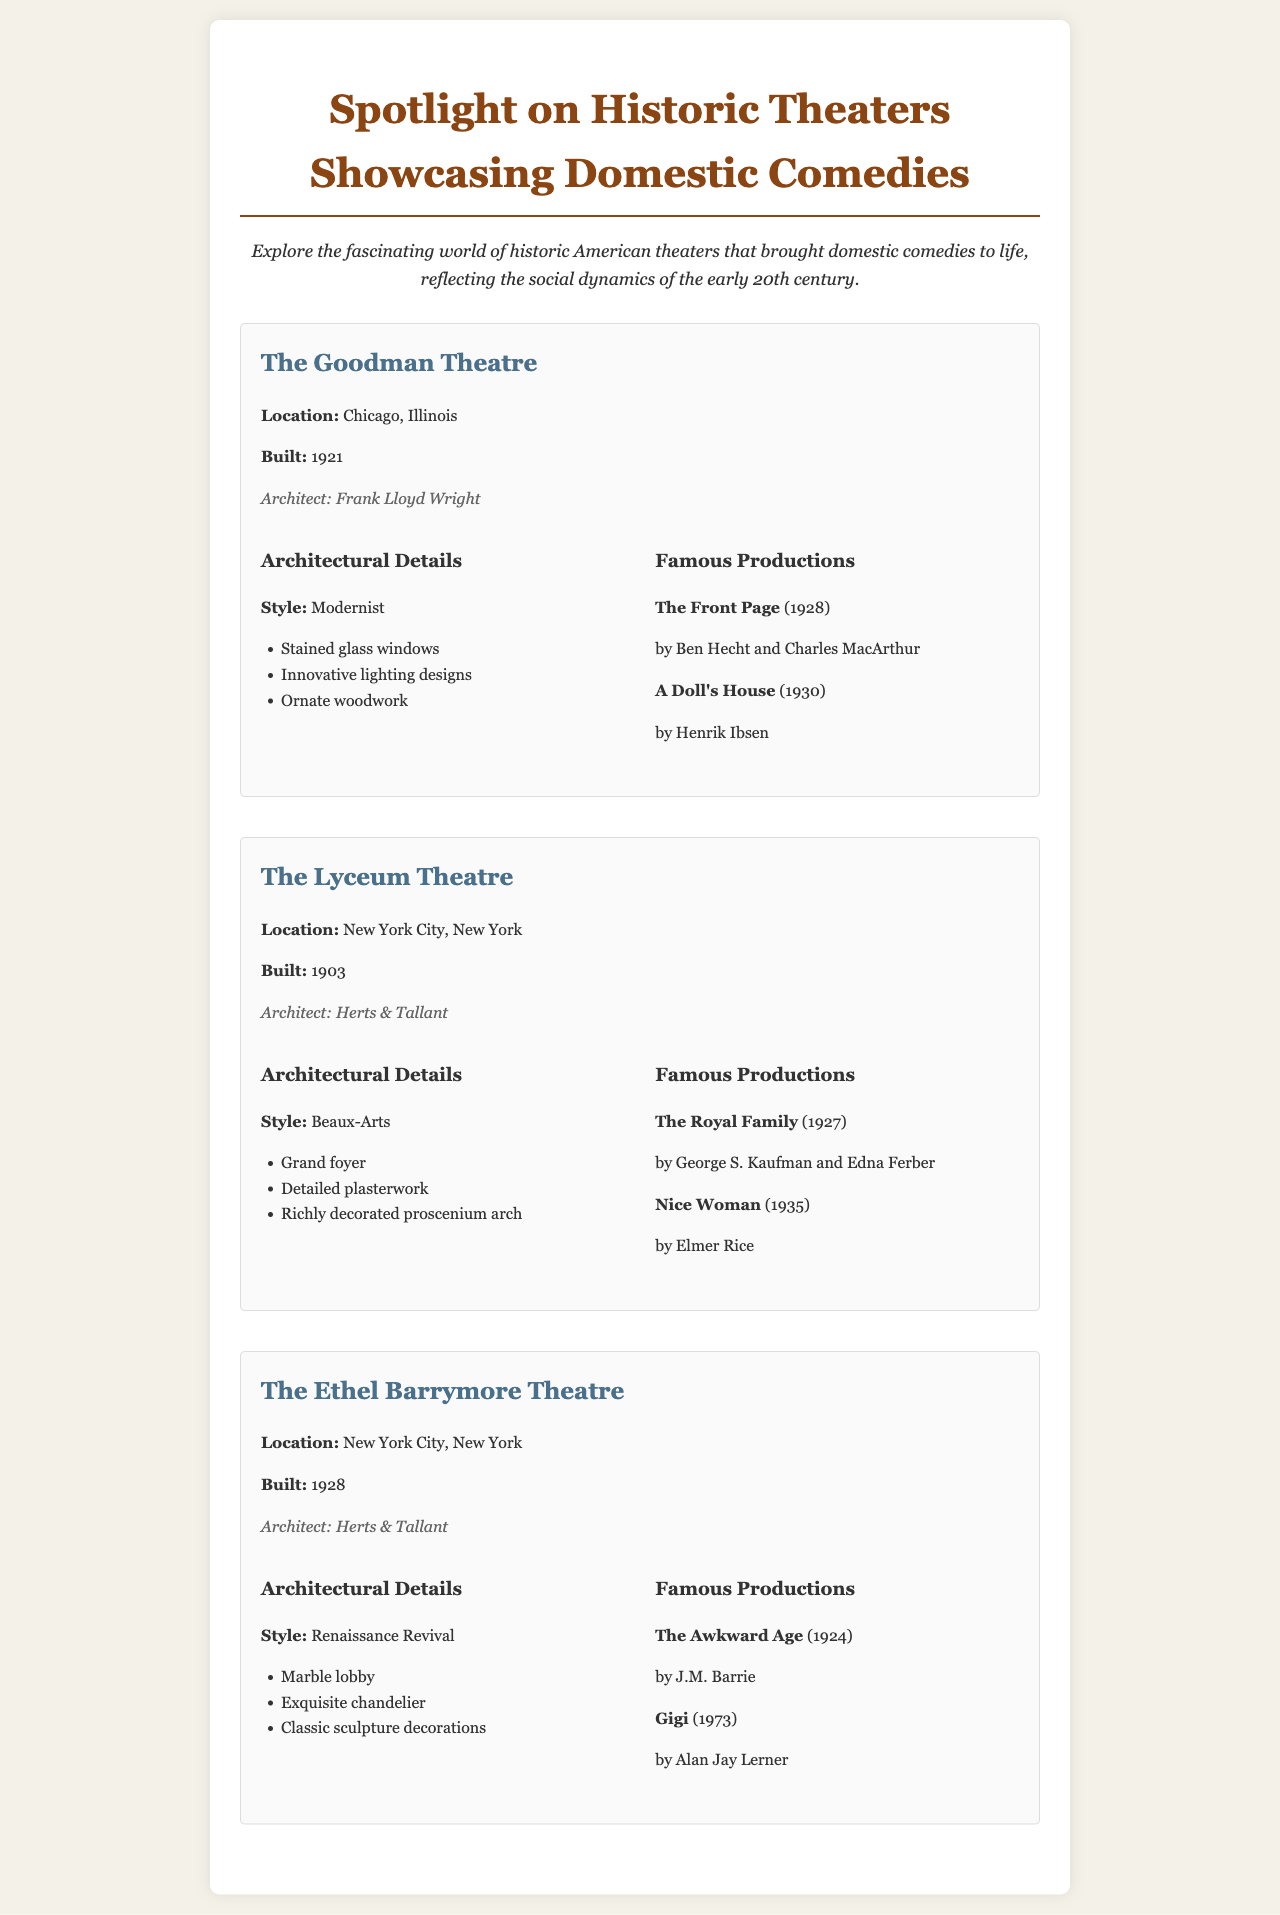What is the location of The Goodman Theatre? The location of The Goodman Theatre is specified in the document as Chicago, Illinois.
Answer: Chicago, Illinois Who is the architect of The Lyceum Theatre? The architect of The Lyceum Theatre is mentioned as Herts & Tallant in the document.
Answer: Herts & Tallant What architectural style is The Ethel Barrymore Theatre? The architectural style is listed as Renaissance Revival in the document.
Answer: Renaissance Revival In what year was The Goodman Theatre built? The year of construction for The Goodman Theatre is provided as 1921 in the document.
Answer: 1921 Which play by George S. Kaufman is mentioned as a famous production at The Lyceum Theatre? The famous production by George S. Kaufman is "The Royal Family", as stated in the document.
Answer: The Royal Family What unique feature does the architectural details of The Goodman Theatre highlight? The architectural details highlight stained glass windows as a unique feature.
Answer: Stained glass windows How many famous productions are listed for The Ethel Barrymore Theatre? The document lists two famous productions for The Ethel Barrymore Theatre.
Answer: Two What year was The Lyceum Theatre constructed? The year of construction for The Lyceum Theatre is given as 1903 in the document.
Answer: 1903 What kind of woodwork is noted in The Goodman Theatre? The document notes ornate woodwork as a feature of The Goodman Theatre.
Answer: Ornate woodwork 